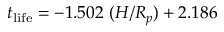Convert formula to latex. <formula><loc_0><loc_0><loc_500><loc_500>t _ { l i f e } = - 1 . 5 0 2 ( H / R _ { p } ) + 2 . 1 8 6</formula> 